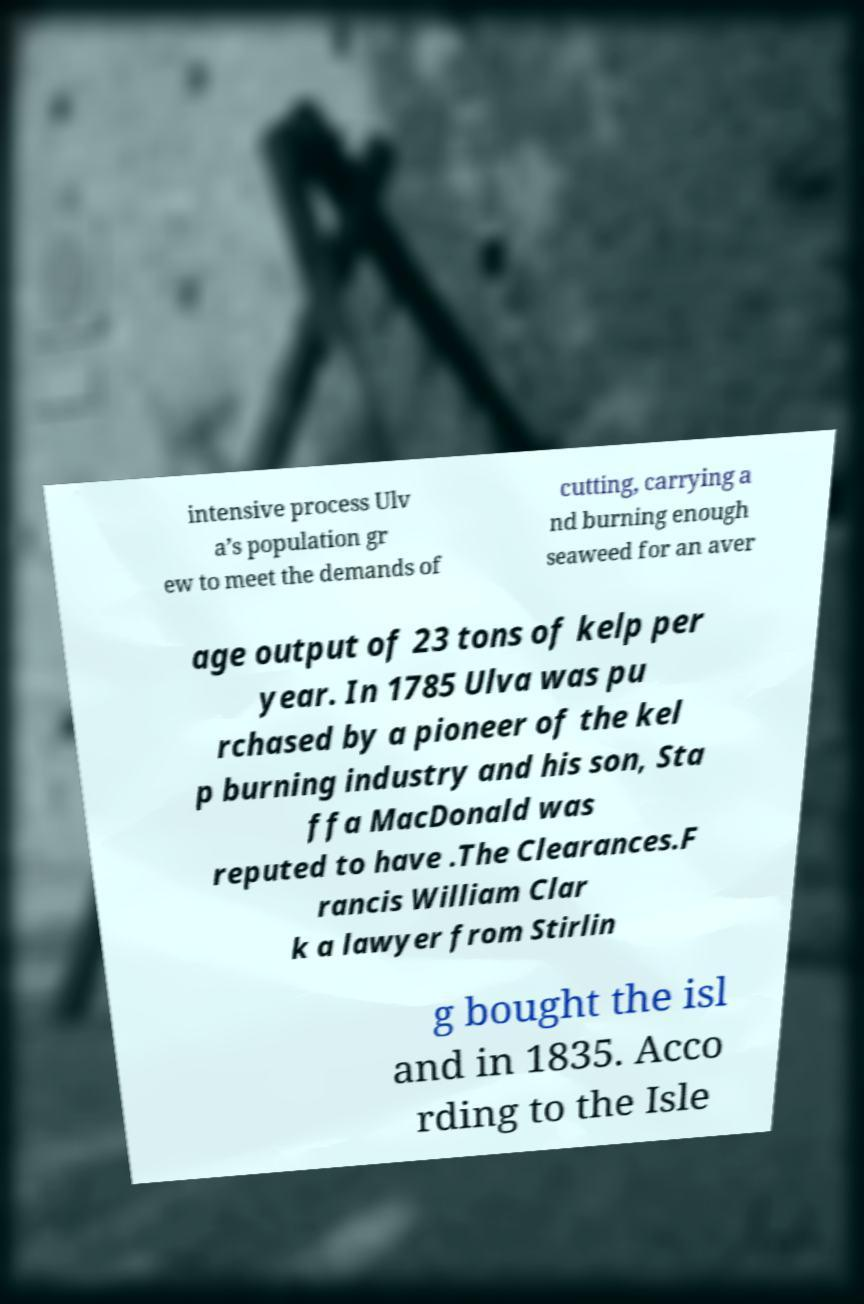Could you extract and type out the text from this image? intensive process Ulv a’s population gr ew to meet the demands of cutting, carrying a nd burning enough seaweed for an aver age output of 23 tons of kelp per year. In 1785 Ulva was pu rchased by a pioneer of the kel p burning industry and his son, Sta ffa MacDonald was reputed to have .The Clearances.F rancis William Clar k a lawyer from Stirlin g bought the isl and in 1835. Acco rding to the Isle 